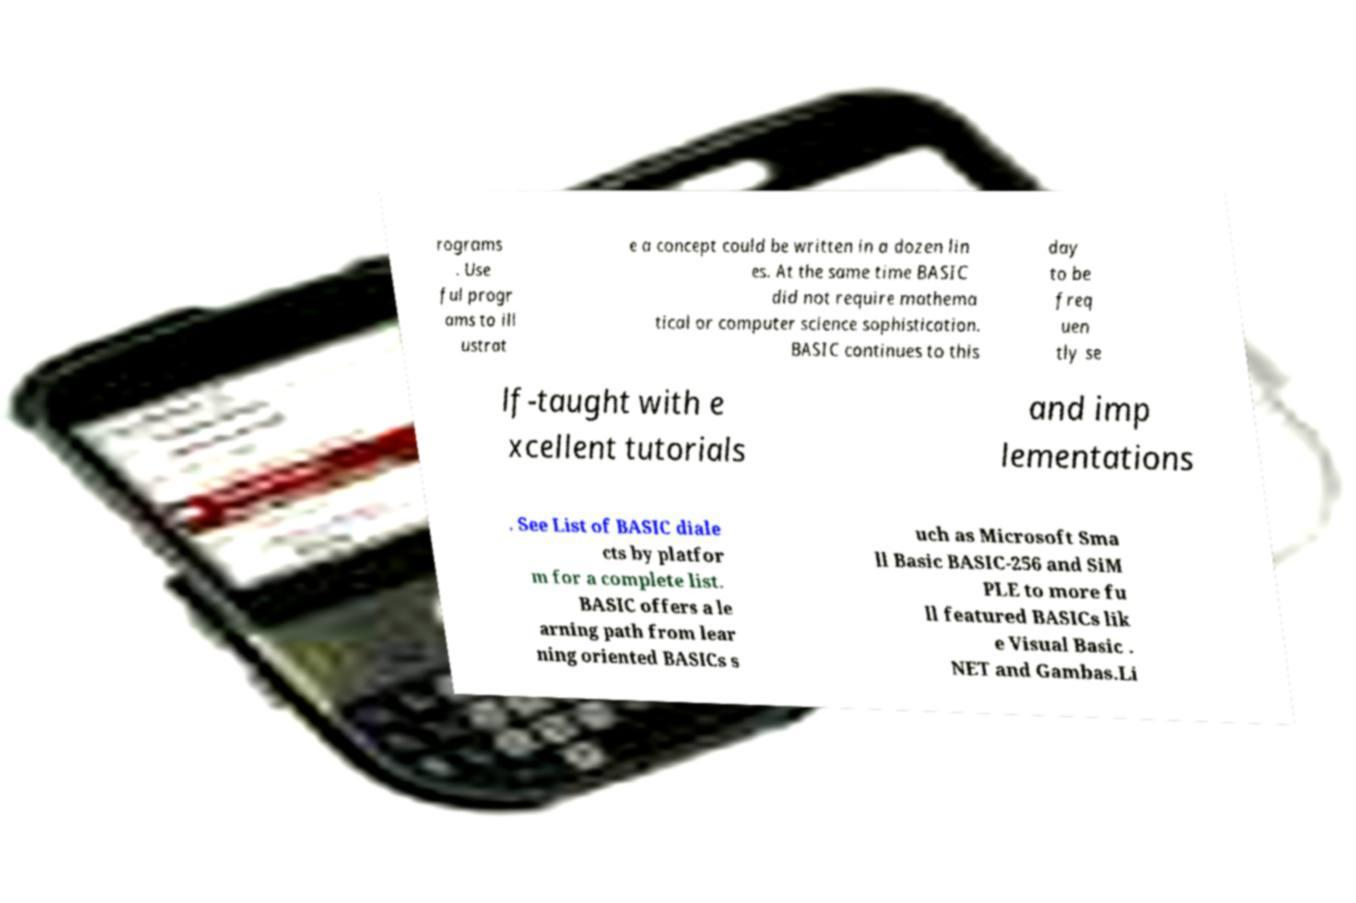For documentation purposes, I need the text within this image transcribed. Could you provide that? rograms . Use ful progr ams to ill ustrat e a concept could be written in a dozen lin es. At the same time BASIC did not require mathema tical or computer science sophistication. BASIC continues to this day to be freq uen tly se lf-taught with e xcellent tutorials and imp lementations . See List of BASIC diale cts by platfor m for a complete list. BASIC offers a le arning path from lear ning oriented BASICs s uch as Microsoft Sma ll Basic BASIC-256 and SiM PLE to more fu ll featured BASICs lik e Visual Basic . NET and Gambas.Li 